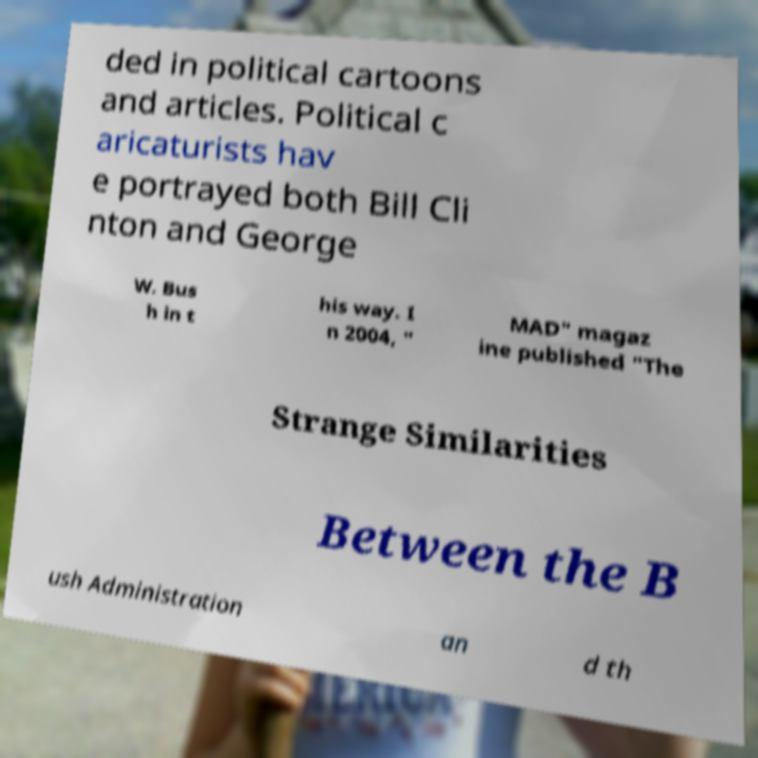Could you assist in decoding the text presented in this image and type it out clearly? ded in political cartoons and articles. Political c aricaturists hav e portrayed both Bill Cli nton and George W. Bus h in t his way. I n 2004, " MAD" magaz ine published "The Strange Similarities Between the B ush Administration an d th 